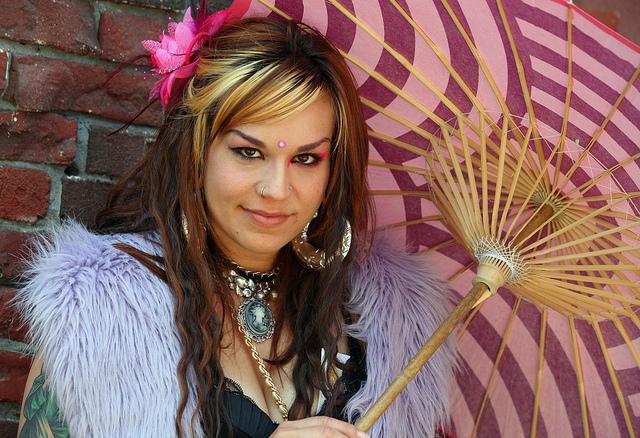Is the girls hair highlighted?
Concise answer only. Yes. What color feathers are on her dress?
Keep it brief. Gray. Why is the umbrella pink?
Give a very brief answer. Design. What is the design on the umbrella?
Be succinct. Stripes. What is the color of the women's dress?
Concise answer only. Black. Is she wearing a mask?
Give a very brief answer. No. What color is the umbrella?
Give a very brief answer. Pink and purple. In which city was this photo taken?
Quick response, please. New york. 